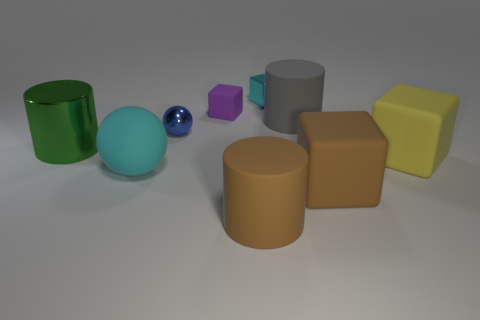Subtract all cubes. How many objects are left? 5 Subtract 0 gray cubes. How many objects are left? 9 Subtract all brown rubber cylinders. Subtract all small shiny balls. How many objects are left? 7 Add 4 big green metal things. How many big green metal things are left? 5 Add 8 small brown spheres. How many small brown spheres exist? 8 